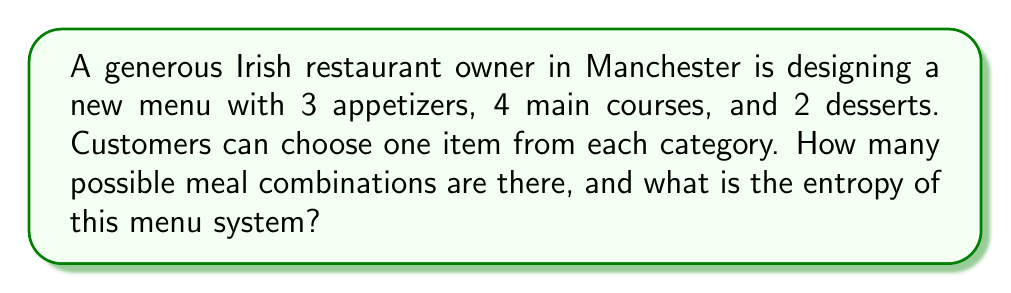What is the answer to this math problem? To solve this problem, we'll follow these steps:

1. Calculate the number of possible meal combinations:
   - Number of appetizers: 3
   - Number of main courses: 4
   - Number of desserts: 2
   Total combinations = $3 \times 4 \times 2 = 24$

2. Calculate the probability of each meal combination:
   Since all combinations are equally likely, the probability of each combination is:
   $p_i = \frac{1}{24}$

3. Calculate the entropy using the Shannon entropy formula:
   $S = -k_B \sum_{i=1}^{N} p_i \ln(p_i)$
   where $k_B$ is Boltzmann's constant (which we'll set to 1 for simplicity)

4. Substitute the values:
   $S = -1 \times 24 \times (\frac{1}{24} \ln(\frac{1}{24}))$

5. Simplify:
   $S = -(\ln(\frac{1}{24})) = \ln(24)$

6. Calculate the final value:
   $S = \ln(24) \approx 3.178$ nats (natural units of information)
Answer: $\ln(24) \approx 3.178$ nats 